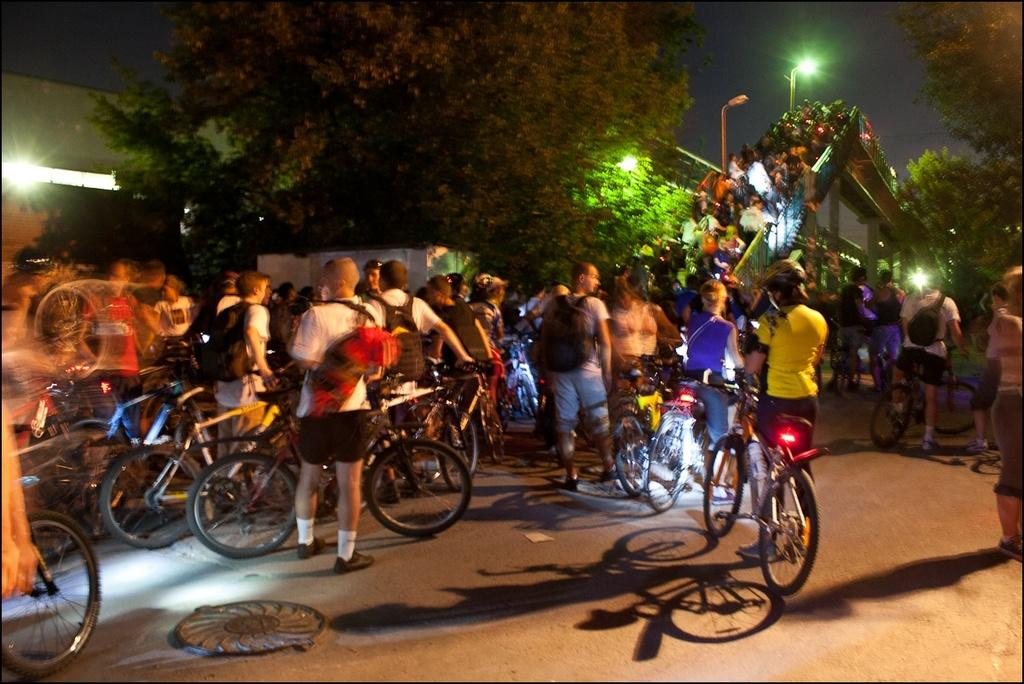How many people are in the image? There are many people in the image. What are the people doing in the image? The people are carrying a bicycle. What can be seen in the background of the image? There is a bridge, trees, street lights, and the sky visible in the background of the image. What type of metal is used to make the kickstand on the bicycle in the image? There is no kickstand visible on the bicycle in the image, so it is not possible to determine the type of metal used. 